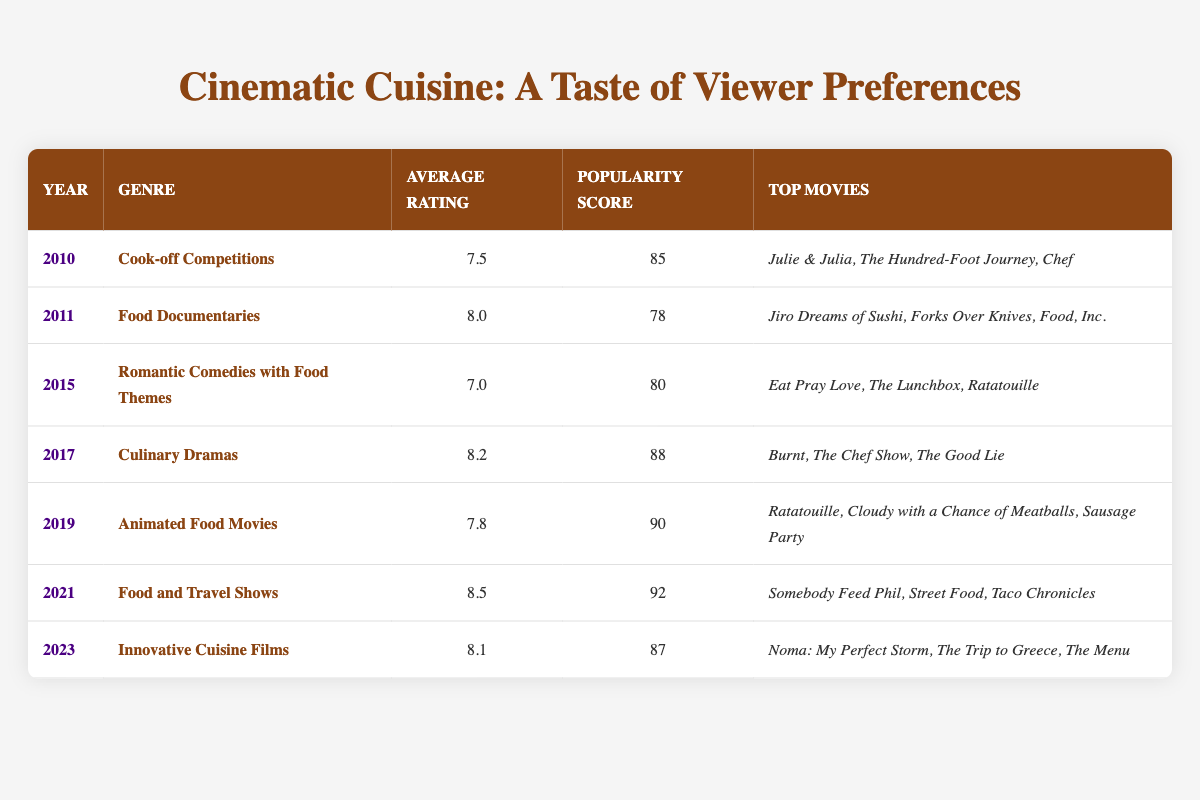What genre had the highest average rating in 2021? The genre in 2021 was "Food and Travel Shows," which had an average rating of 8.5. This value can be found directly in the table under the 2021 row.
Answer: Food and Travel Shows What were the top movies listed for Culinary Dramas? According to the table, the top movies for the genre "Culinary Dramas" in 2017 are "Burnt," "The Chef Show," and "The Good Lie." This information is in the row corresponding to the year 2017.
Answer: Burnt, The Chef Show, The Good Lie What is the average popularity score of all genres listed in the table? To calculate the average popularity score, we sum the values (85 + 78 + 80 + 88 + 90 + 92 + 87) which equals 600. Then, divide by the number of genres (7) which gives us an average of 600/7 approximately equal to 85.71.
Answer: 85.71 Did the popularity score for Animated Food Movies in 2019 exceed that of Food Documentaries in 2011? The popularity score for Animated Food Movies in 2019 is 90, while the score for Food Documentaries in 2011 is 78. Since 90 is greater than 78, the answer is yes.
Answer: Yes Which genre had a lower average rating: Romantic Comedies with Food Themes or Cook-off Competitions? The average rating for Romantic Comedies with Food Themes in 2015 is 7.0, while Cook-off Competitions in 2010 had an average rating of 7.5. Since 7.0 is less than 7.5, Romantic Comedies with Food Themes had a lower average rating.
Answer: Romantic Comedies with Food Themes What year did Food and Travel Shows have the highest popularity score? The genre "Food and Travel Shows" was listed in 2021 with a popularity score of 92. This is the highest score when compared with the popularity scores from other years in the table.
Answer: 2021 Is there a genre that had an average rating of exactly 8.0? Yes, the genre "Food Documentaries" in 2011 had an average rating of 8.0. This is stated clearly in the corresponding row for 2011.
Answer: Yes What was the average rating of Culinary Dramas in 2017 compared to Innovative Cuisine Films in 2023? The average rating for Culinary Dramas in 2017 is 8.2, and for Innovative Cuisine Films in 2023, it is 8.1. Comparing these values shows that 8.2 is greater than 8.1, indicating Culinary Dramas had a higher average rating.
Answer: Culinary Dramas had a higher average rating 